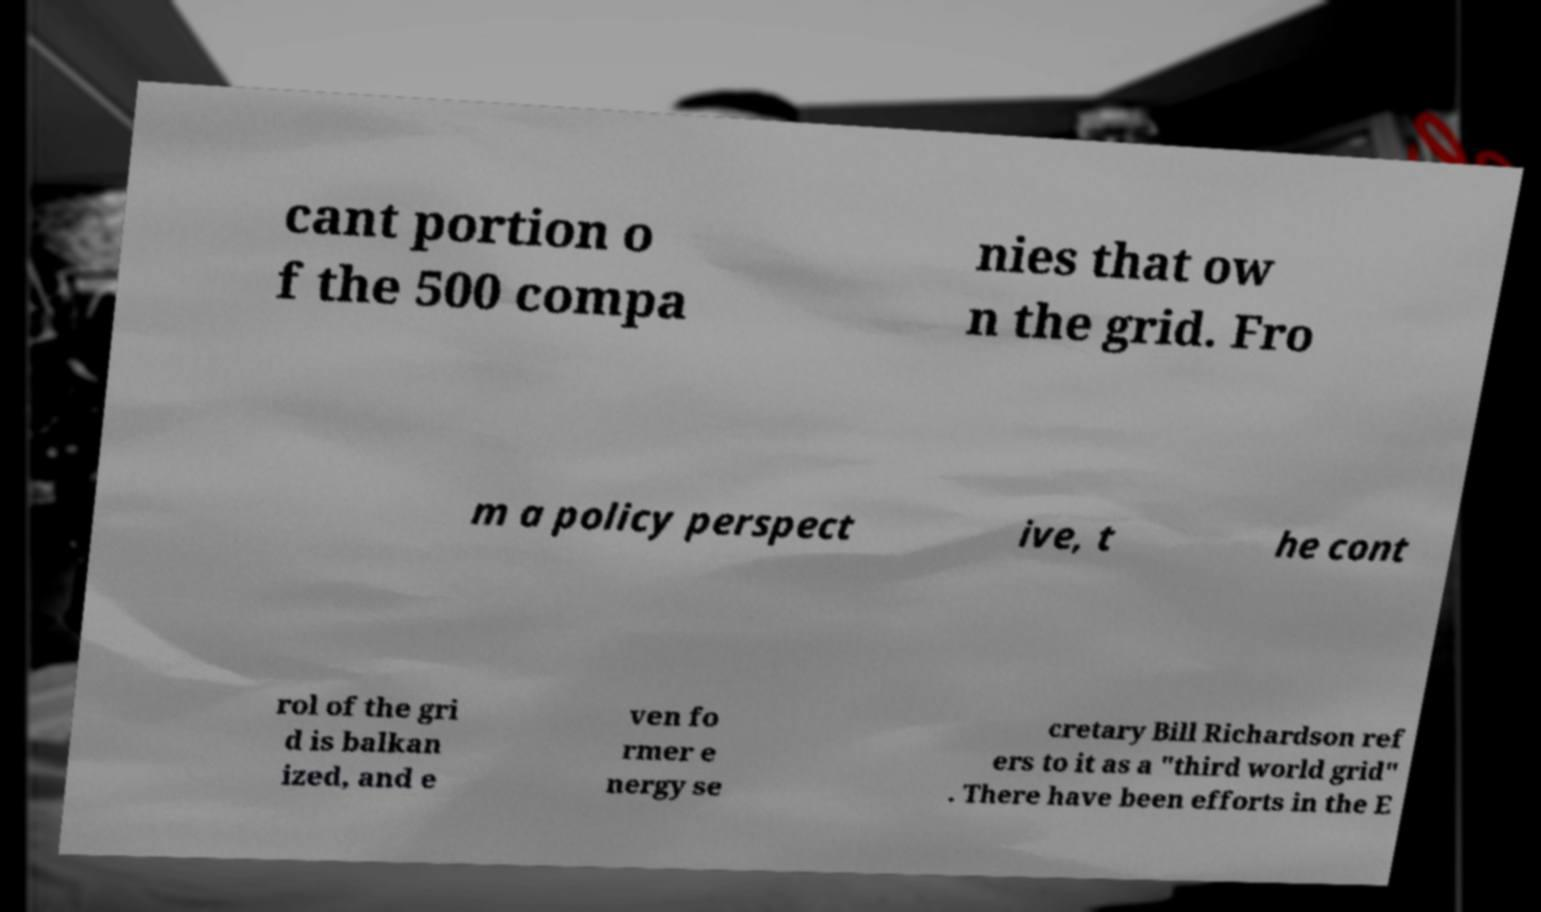Could you assist in decoding the text presented in this image and type it out clearly? cant portion o f the 500 compa nies that ow n the grid. Fro m a policy perspect ive, t he cont rol of the gri d is balkan ized, and e ven fo rmer e nergy se cretary Bill Richardson ref ers to it as a "third world grid" . There have been efforts in the E 